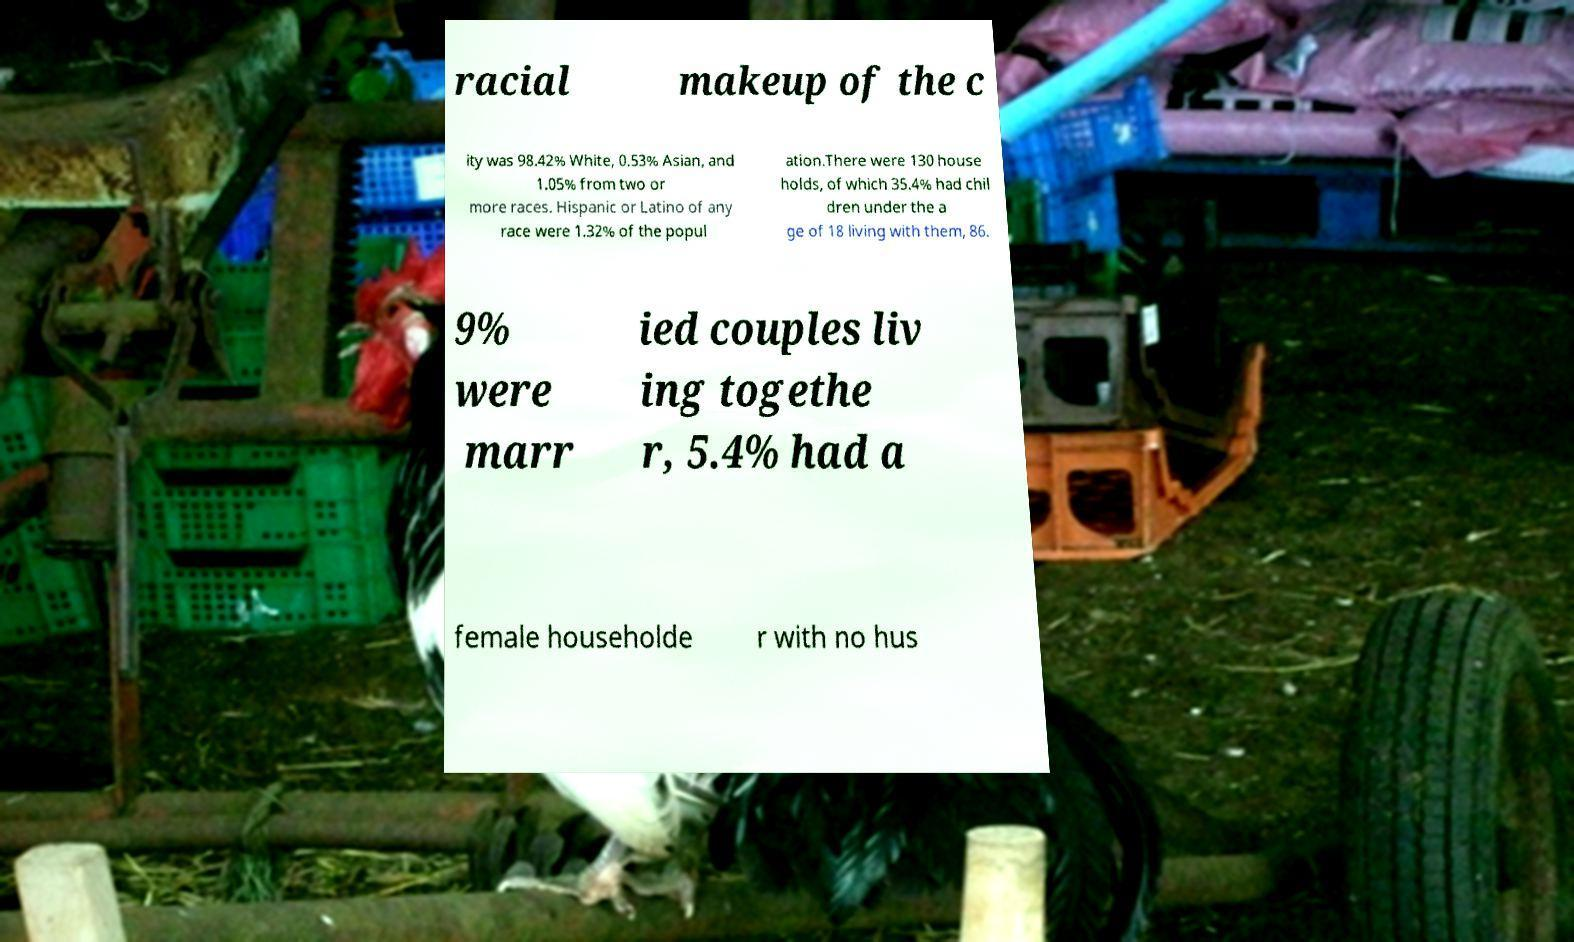I need the written content from this picture converted into text. Can you do that? racial makeup of the c ity was 98.42% White, 0.53% Asian, and 1.05% from two or more races. Hispanic or Latino of any race were 1.32% of the popul ation.There were 130 house holds, of which 35.4% had chil dren under the a ge of 18 living with them, 86. 9% were marr ied couples liv ing togethe r, 5.4% had a female householde r with no hus 